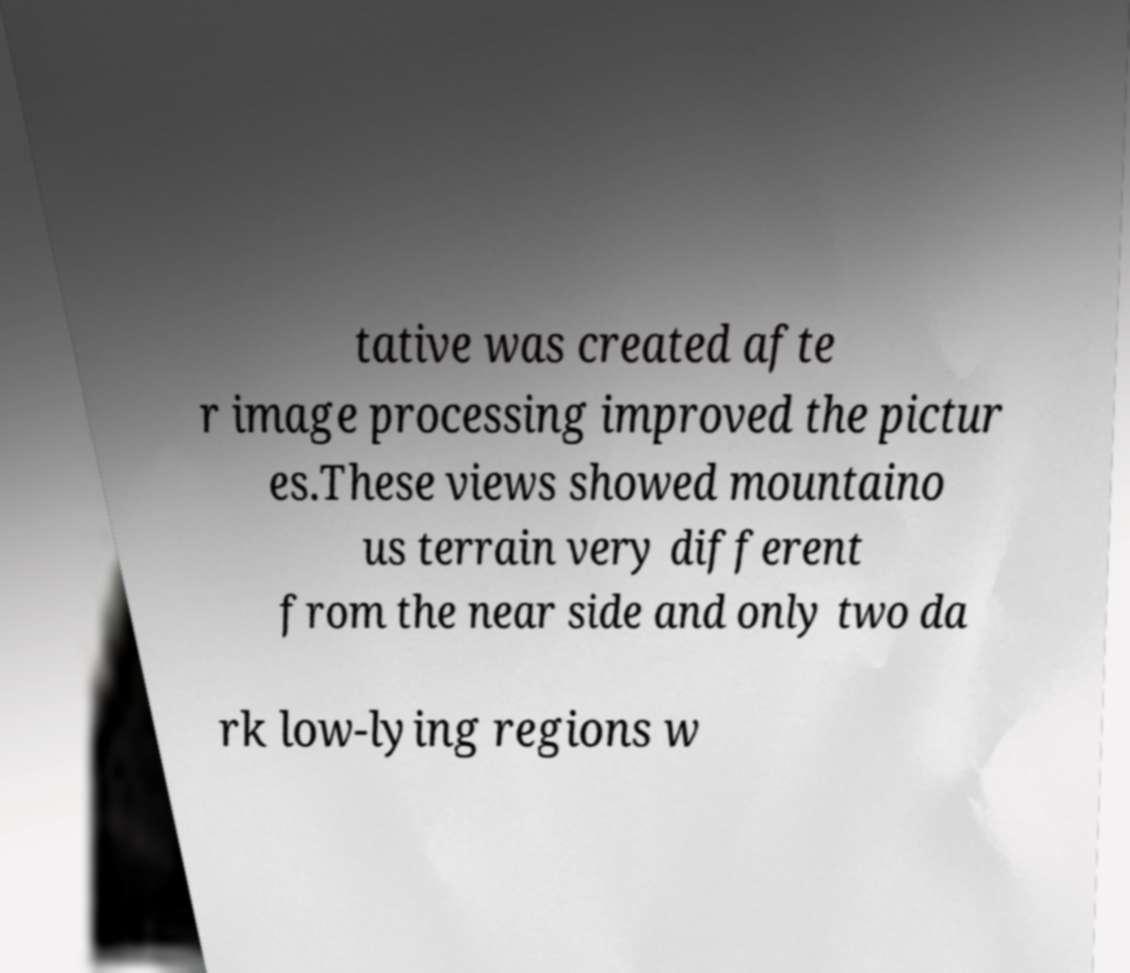I need the written content from this picture converted into text. Can you do that? tative was created afte r image processing improved the pictur es.These views showed mountaino us terrain very different from the near side and only two da rk low-lying regions w 